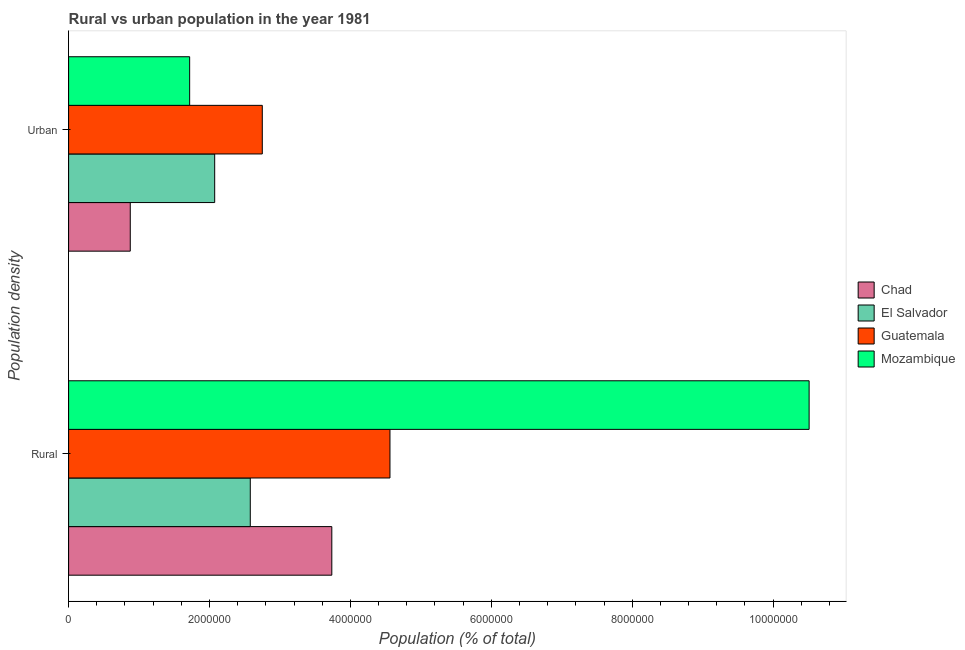How many different coloured bars are there?
Ensure brevity in your answer.  4. Are the number of bars per tick equal to the number of legend labels?
Ensure brevity in your answer.  Yes. Are the number of bars on each tick of the Y-axis equal?
Your answer should be very brief. Yes. How many bars are there on the 1st tick from the bottom?
Keep it short and to the point. 4. What is the label of the 2nd group of bars from the top?
Make the answer very short. Rural. What is the rural population density in Chad?
Keep it short and to the point. 3.74e+06. Across all countries, what is the maximum rural population density?
Offer a very short reply. 1.05e+07. Across all countries, what is the minimum rural population density?
Give a very brief answer. 2.58e+06. In which country was the urban population density maximum?
Give a very brief answer. Guatemala. In which country was the urban population density minimum?
Keep it short and to the point. Chad. What is the total urban population density in the graph?
Your answer should be compact. 7.42e+06. What is the difference between the urban population density in Guatemala and that in Chad?
Your response must be concise. 1.87e+06. What is the difference between the urban population density in El Salvador and the rural population density in Guatemala?
Offer a very short reply. -2.49e+06. What is the average rural population density per country?
Provide a short and direct response. 5.35e+06. What is the difference between the rural population density and urban population density in Guatemala?
Offer a very short reply. 1.81e+06. What is the ratio of the urban population density in El Salvador to that in Guatemala?
Your answer should be very brief. 0.75. Is the urban population density in Chad less than that in Guatemala?
Provide a succinct answer. Yes. What does the 2nd bar from the top in Rural represents?
Ensure brevity in your answer.  Guatemala. What does the 1st bar from the bottom in Urban represents?
Keep it short and to the point. Chad. How many bars are there?
Offer a terse response. 8. Are the values on the major ticks of X-axis written in scientific E-notation?
Your answer should be very brief. No. Does the graph contain any zero values?
Give a very brief answer. No. Where does the legend appear in the graph?
Provide a succinct answer. Center right. How many legend labels are there?
Your answer should be very brief. 4. What is the title of the graph?
Keep it short and to the point. Rural vs urban population in the year 1981. Does "Jordan" appear as one of the legend labels in the graph?
Keep it short and to the point. No. What is the label or title of the X-axis?
Offer a terse response. Population (% of total). What is the label or title of the Y-axis?
Provide a succinct answer. Population density. What is the Population (% of total) of Chad in Rural?
Offer a very short reply. 3.74e+06. What is the Population (% of total) in El Salvador in Rural?
Offer a very short reply. 2.58e+06. What is the Population (% of total) of Guatemala in Rural?
Offer a very short reply. 4.56e+06. What is the Population (% of total) in Mozambique in Rural?
Your answer should be very brief. 1.05e+07. What is the Population (% of total) in Chad in Urban?
Offer a terse response. 8.75e+05. What is the Population (% of total) of El Salvador in Urban?
Offer a terse response. 2.07e+06. What is the Population (% of total) in Guatemala in Urban?
Keep it short and to the point. 2.75e+06. What is the Population (% of total) in Mozambique in Urban?
Give a very brief answer. 1.72e+06. Across all Population density, what is the maximum Population (% of total) of Chad?
Your answer should be very brief. 3.74e+06. Across all Population density, what is the maximum Population (% of total) in El Salvador?
Offer a terse response. 2.58e+06. Across all Population density, what is the maximum Population (% of total) of Guatemala?
Your response must be concise. 4.56e+06. Across all Population density, what is the maximum Population (% of total) of Mozambique?
Your response must be concise. 1.05e+07. Across all Population density, what is the minimum Population (% of total) in Chad?
Make the answer very short. 8.75e+05. Across all Population density, what is the minimum Population (% of total) of El Salvador?
Your answer should be very brief. 2.07e+06. Across all Population density, what is the minimum Population (% of total) of Guatemala?
Your answer should be compact. 2.75e+06. Across all Population density, what is the minimum Population (% of total) of Mozambique?
Make the answer very short. 1.72e+06. What is the total Population (% of total) of Chad in the graph?
Provide a short and direct response. 4.61e+06. What is the total Population (% of total) of El Salvador in the graph?
Make the answer very short. 4.65e+06. What is the total Population (% of total) of Guatemala in the graph?
Your answer should be compact. 7.31e+06. What is the total Population (% of total) of Mozambique in the graph?
Provide a succinct answer. 1.22e+07. What is the difference between the Population (% of total) in Chad in Rural and that in Urban?
Your answer should be compact. 2.86e+06. What is the difference between the Population (% of total) in El Salvador in Rural and that in Urban?
Your answer should be compact. 5.05e+05. What is the difference between the Population (% of total) of Guatemala in Rural and that in Urban?
Make the answer very short. 1.81e+06. What is the difference between the Population (% of total) of Mozambique in Rural and that in Urban?
Give a very brief answer. 8.79e+06. What is the difference between the Population (% of total) in Chad in Rural and the Population (% of total) in El Salvador in Urban?
Give a very brief answer. 1.66e+06. What is the difference between the Population (% of total) of Chad in Rural and the Population (% of total) of Guatemala in Urban?
Give a very brief answer. 9.87e+05. What is the difference between the Population (% of total) in Chad in Rural and the Population (% of total) in Mozambique in Urban?
Give a very brief answer. 2.02e+06. What is the difference between the Population (% of total) of El Salvador in Rural and the Population (% of total) of Guatemala in Urban?
Your answer should be compact. -1.70e+05. What is the difference between the Population (% of total) in El Salvador in Rural and the Population (% of total) in Mozambique in Urban?
Offer a very short reply. 8.60e+05. What is the difference between the Population (% of total) in Guatemala in Rural and the Population (% of total) in Mozambique in Urban?
Ensure brevity in your answer.  2.84e+06. What is the average Population (% of total) in Chad per Population density?
Give a very brief answer. 2.31e+06. What is the average Population (% of total) of El Salvador per Population density?
Your response must be concise. 2.33e+06. What is the average Population (% of total) in Guatemala per Population density?
Give a very brief answer. 3.66e+06. What is the average Population (% of total) in Mozambique per Population density?
Provide a short and direct response. 6.11e+06. What is the difference between the Population (% of total) in Chad and Population (% of total) in El Salvador in Rural?
Ensure brevity in your answer.  1.16e+06. What is the difference between the Population (% of total) of Chad and Population (% of total) of Guatemala in Rural?
Provide a short and direct response. -8.26e+05. What is the difference between the Population (% of total) in Chad and Population (% of total) in Mozambique in Rural?
Your answer should be very brief. -6.77e+06. What is the difference between the Population (% of total) of El Salvador and Population (% of total) of Guatemala in Rural?
Provide a succinct answer. -1.98e+06. What is the difference between the Population (% of total) of El Salvador and Population (% of total) of Mozambique in Rural?
Your answer should be very brief. -7.93e+06. What is the difference between the Population (% of total) in Guatemala and Population (% of total) in Mozambique in Rural?
Provide a succinct answer. -5.95e+06. What is the difference between the Population (% of total) in Chad and Population (% of total) in El Salvador in Urban?
Your answer should be very brief. -1.20e+06. What is the difference between the Population (% of total) of Chad and Population (% of total) of Guatemala in Urban?
Provide a succinct answer. -1.87e+06. What is the difference between the Population (% of total) in Chad and Population (% of total) in Mozambique in Urban?
Offer a terse response. -8.43e+05. What is the difference between the Population (% of total) of El Salvador and Population (% of total) of Guatemala in Urban?
Provide a short and direct response. -6.76e+05. What is the difference between the Population (% of total) in El Salvador and Population (% of total) in Mozambique in Urban?
Make the answer very short. 3.55e+05. What is the difference between the Population (% of total) of Guatemala and Population (% of total) of Mozambique in Urban?
Your answer should be very brief. 1.03e+06. What is the ratio of the Population (% of total) of Chad in Rural to that in Urban?
Your response must be concise. 4.27. What is the ratio of the Population (% of total) of El Salvador in Rural to that in Urban?
Ensure brevity in your answer.  1.24. What is the ratio of the Population (% of total) in Guatemala in Rural to that in Urban?
Offer a very short reply. 1.66. What is the ratio of the Population (% of total) of Mozambique in Rural to that in Urban?
Provide a succinct answer. 6.12. What is the difference between the highest and the second highest Population (% of total) in Chad?
Ensure brevity in your answer.  2.86e+06. What is the difference between the highest and the second highest Population (% of total) in El Salvador?
Your response must be concise. 5.05e+05. What is the difference between the highest and the second highest Population (% of total) of Guatemala?
Ensure brevity in your answer.  1.81e+06. What is the difference between the highest and the second highest Population (% of total) of Mozambique?
Your answer should be very brief. 8.79e+06. What is the difference between the highest and the lowest Population (% of total) in Chad?
Provide a succinct answer. 2.86e+06. What is the difference between the highest and the lowest Population (% of total) of El Salvador?
Make the answer very short. 5.05e+05. What is the difference between the highest and the lowest Population (% of total) in Guatemala?
Make the answer very short. 1.81e+06. What is the difference between the highest and the lowest Population (% of total) in Mozambique?
Offer a terse response. 8.79e+06. 